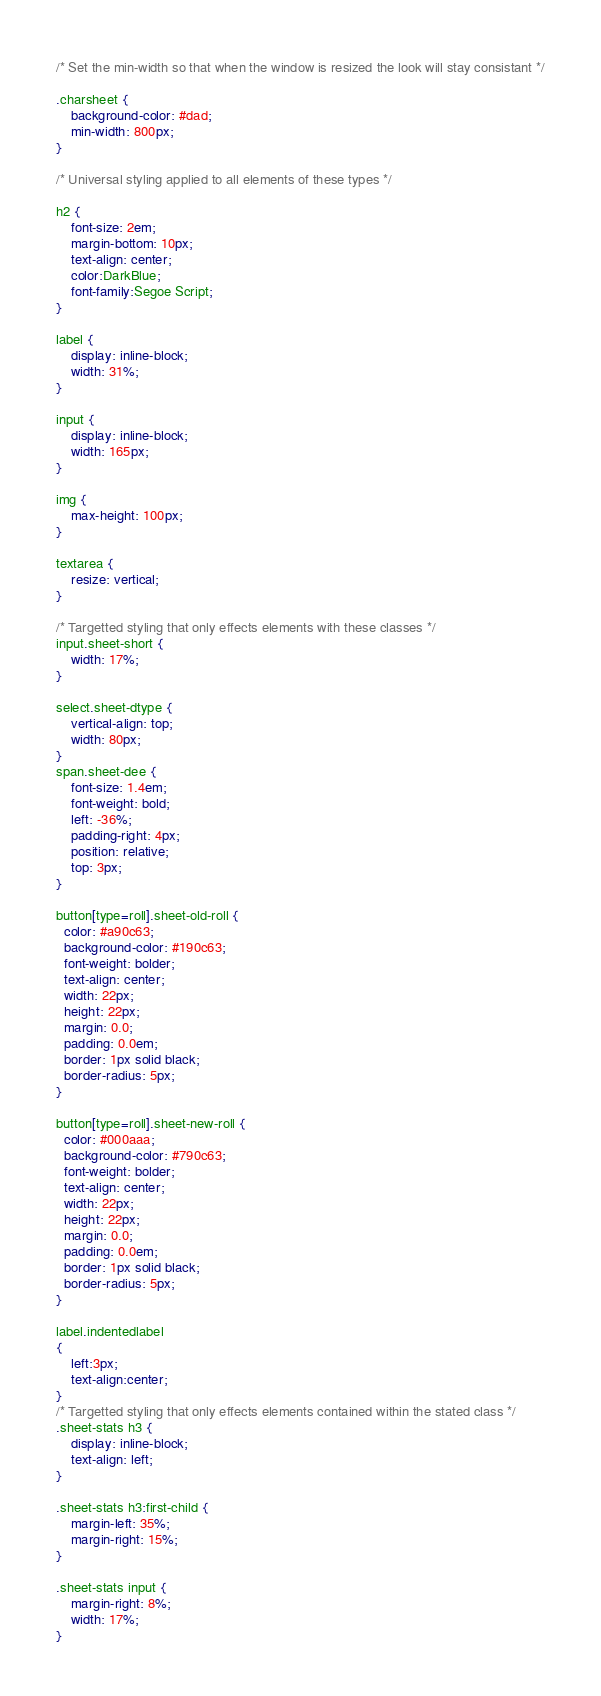Convert code to text. <code><loc_0><loc_0><loc_500><loc_500><_CSS_>/* Set the min-width so that when the window is resized the look will stay consistant */

.charsheet {
	background-color: #dad;
	min-width: 800px;
}

/* Universal styling applied to all elements of these types */

h2 {
	font-size: 2em;
	margin-bottom: 10px;
	text-align: center;
	color:DarkBlue;
	font-family:Segoe Script;
}

label {
	display: inline-block;
	width: 31%;
}

input {
	display: inline-block;
	width: 165px;
}

img {
	max-height: 100px;
}

textarea {
	resize: vertical;
}

/* Targetted styling that only effects elements with these classes */
input.sheet-short {
	width: 17%;
}

select.sheet-dtype {
    vertical-align: top;
    width: 80px;
}
span.sheet-dee {
	font-size: 1.4em;
	font-weight: bold;
	left: -36%;
	padding-right: 4px;
	position: relative;
	top: 3px;
}

button[type=roll].sheet-old-roll {
  color: #a90c63;
  background-color: #190c63;
  font-weight: bolder;
  text-align: center;
  width: 22px;
  height: 22px;
  margin: 0.0;
  padding: 0.0em;
  border: 1px solid black;
  border-radius: 5px;
}

button[type=roll].sheet-new-roll {
  color: #000aaa;
  background-color: #790c63;
  font-weight: bolder;
  text-align: center;
  width: 22px;
  height: 22px;
  margin: 0.0;
  padding: 0.0em;
  border: 1px solid black;
  border-radius: 5px;
}

label.indentedlabel
{
	left:3px;
	text-align:center;
}
/* Targetted styling that only effects elements contained within the stated class */
.sheet-stats h3 {
	display: inline-block;
	text-align: left;
}

.sheet-stats h3:first-child {
	margin-left: 35%;
	margin-right: 15%;
}

.sheet-stats input {
	margin-right: 8%;
	width: 17%;
}</code> 